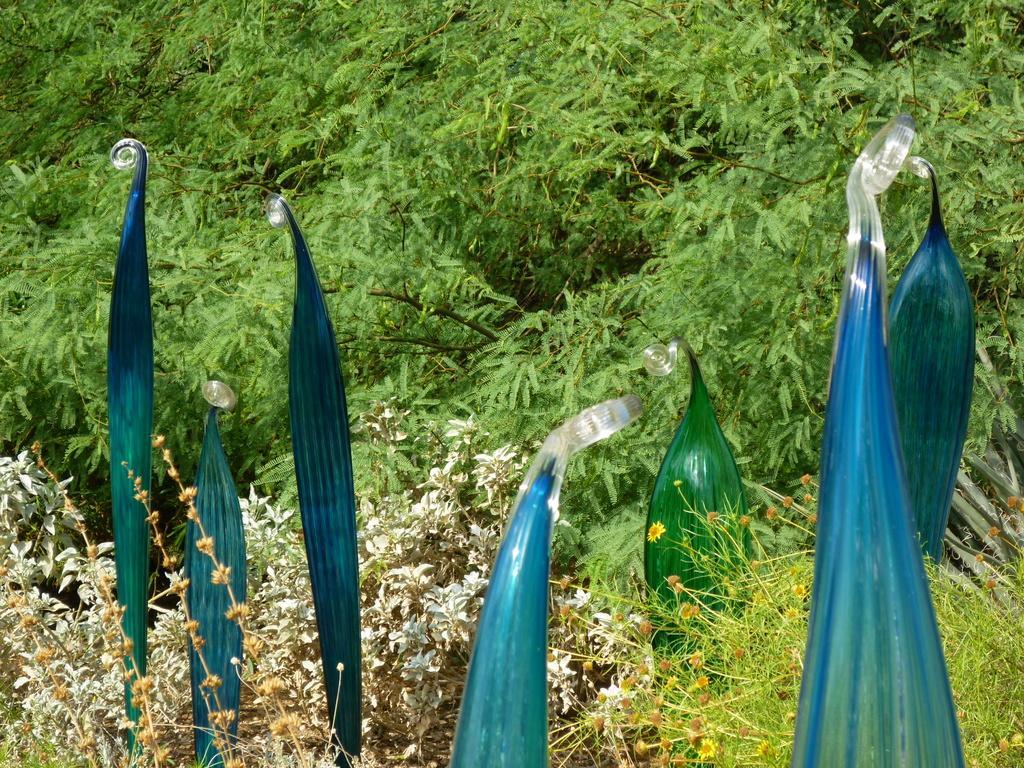Describe this image in one or two sentences. In this picture there are leaves in the foreground area of the image and there is greenery around the area of the image. 